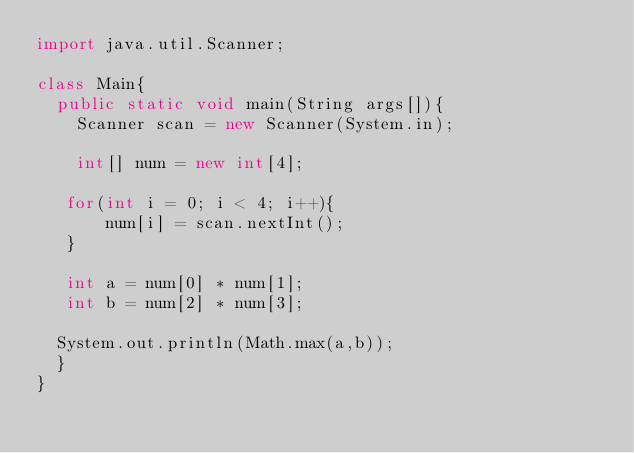Convert code to text. <code><loc_0><loc_0><loc_500><loc_500><_Java_>import java.util.Scanner;

class Main{
  public static void main(String args[]){
    Scanner scan = new Scanner(System.in);

    int[] num = new int[4];

   for(int i = 0; i < 4; i++){
       num[i] = scan.nextInt();
   }

   int a = num[0] * num[1];
   int b = num[2] * num[3]; 

  System.out.println(Math.max(a,b));
  }
}</code> 